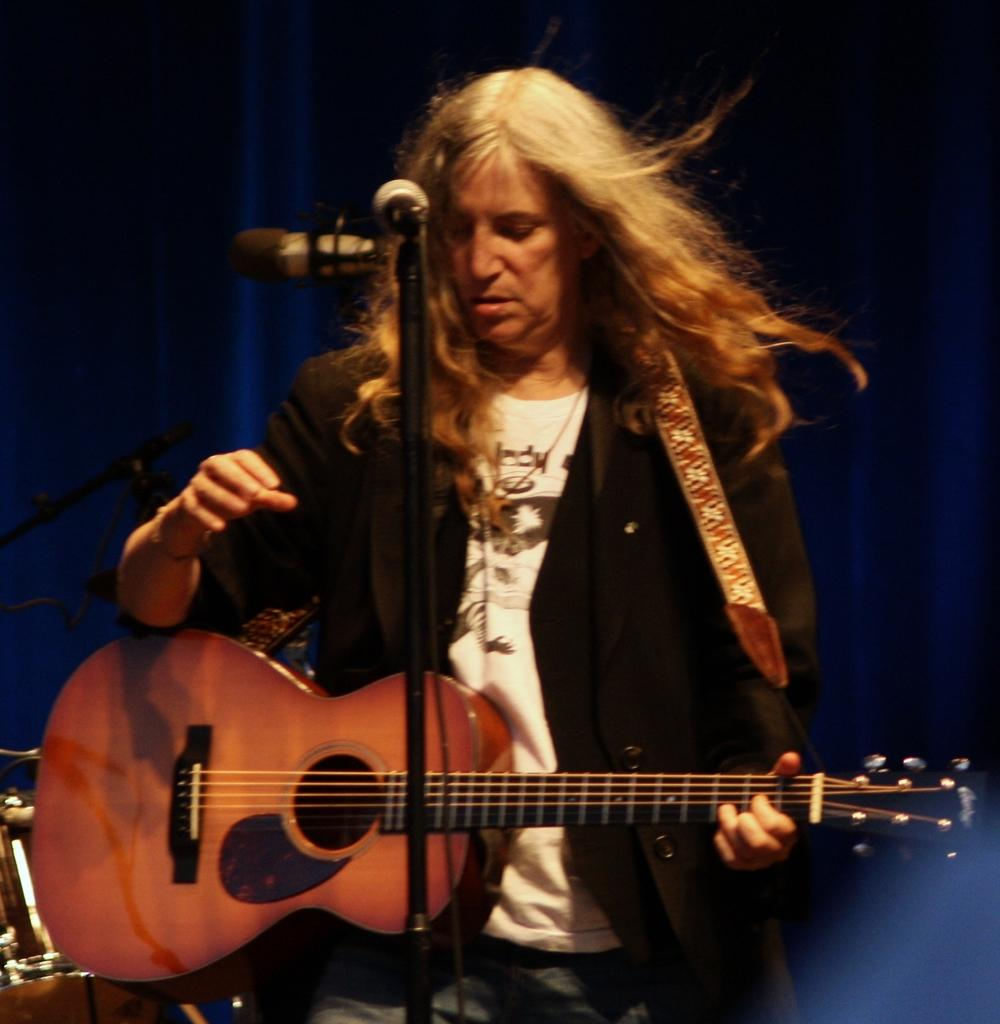Who is the main subject in the image? There is a woman in the image. What is the woman doing in the image? The woman is standing and holding a guitar. What object is in front of the woman? There is a microphone in front of the woman. How many pears can be seen on the woman's fingers in the image? There are no pears present in the image, and the woman's fingers are not visible. 